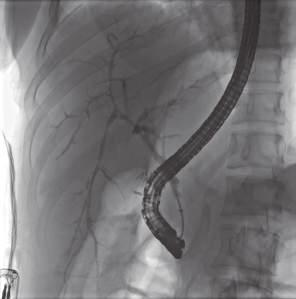s a bile duct undergoing degeneration entrapped in a dense, onion-skin concentric scar?
Answer the question using a single word or phrase. Yes 